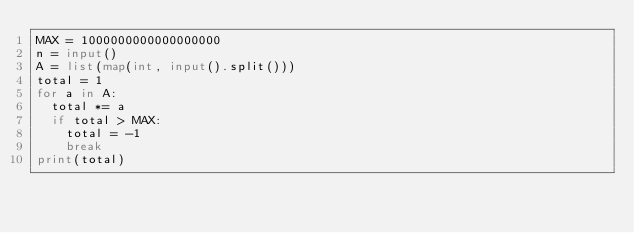Convert code to text. <code><loc_0><loc_0><loc_500><loc_500><_Python_>MAX = 1000000000000000000
n = input()
A = list(map(int, input().split()))
total = 1
for a in A:
  total *= a
  if total > MAX:
    total = -1
    break
print(total)
</code> 